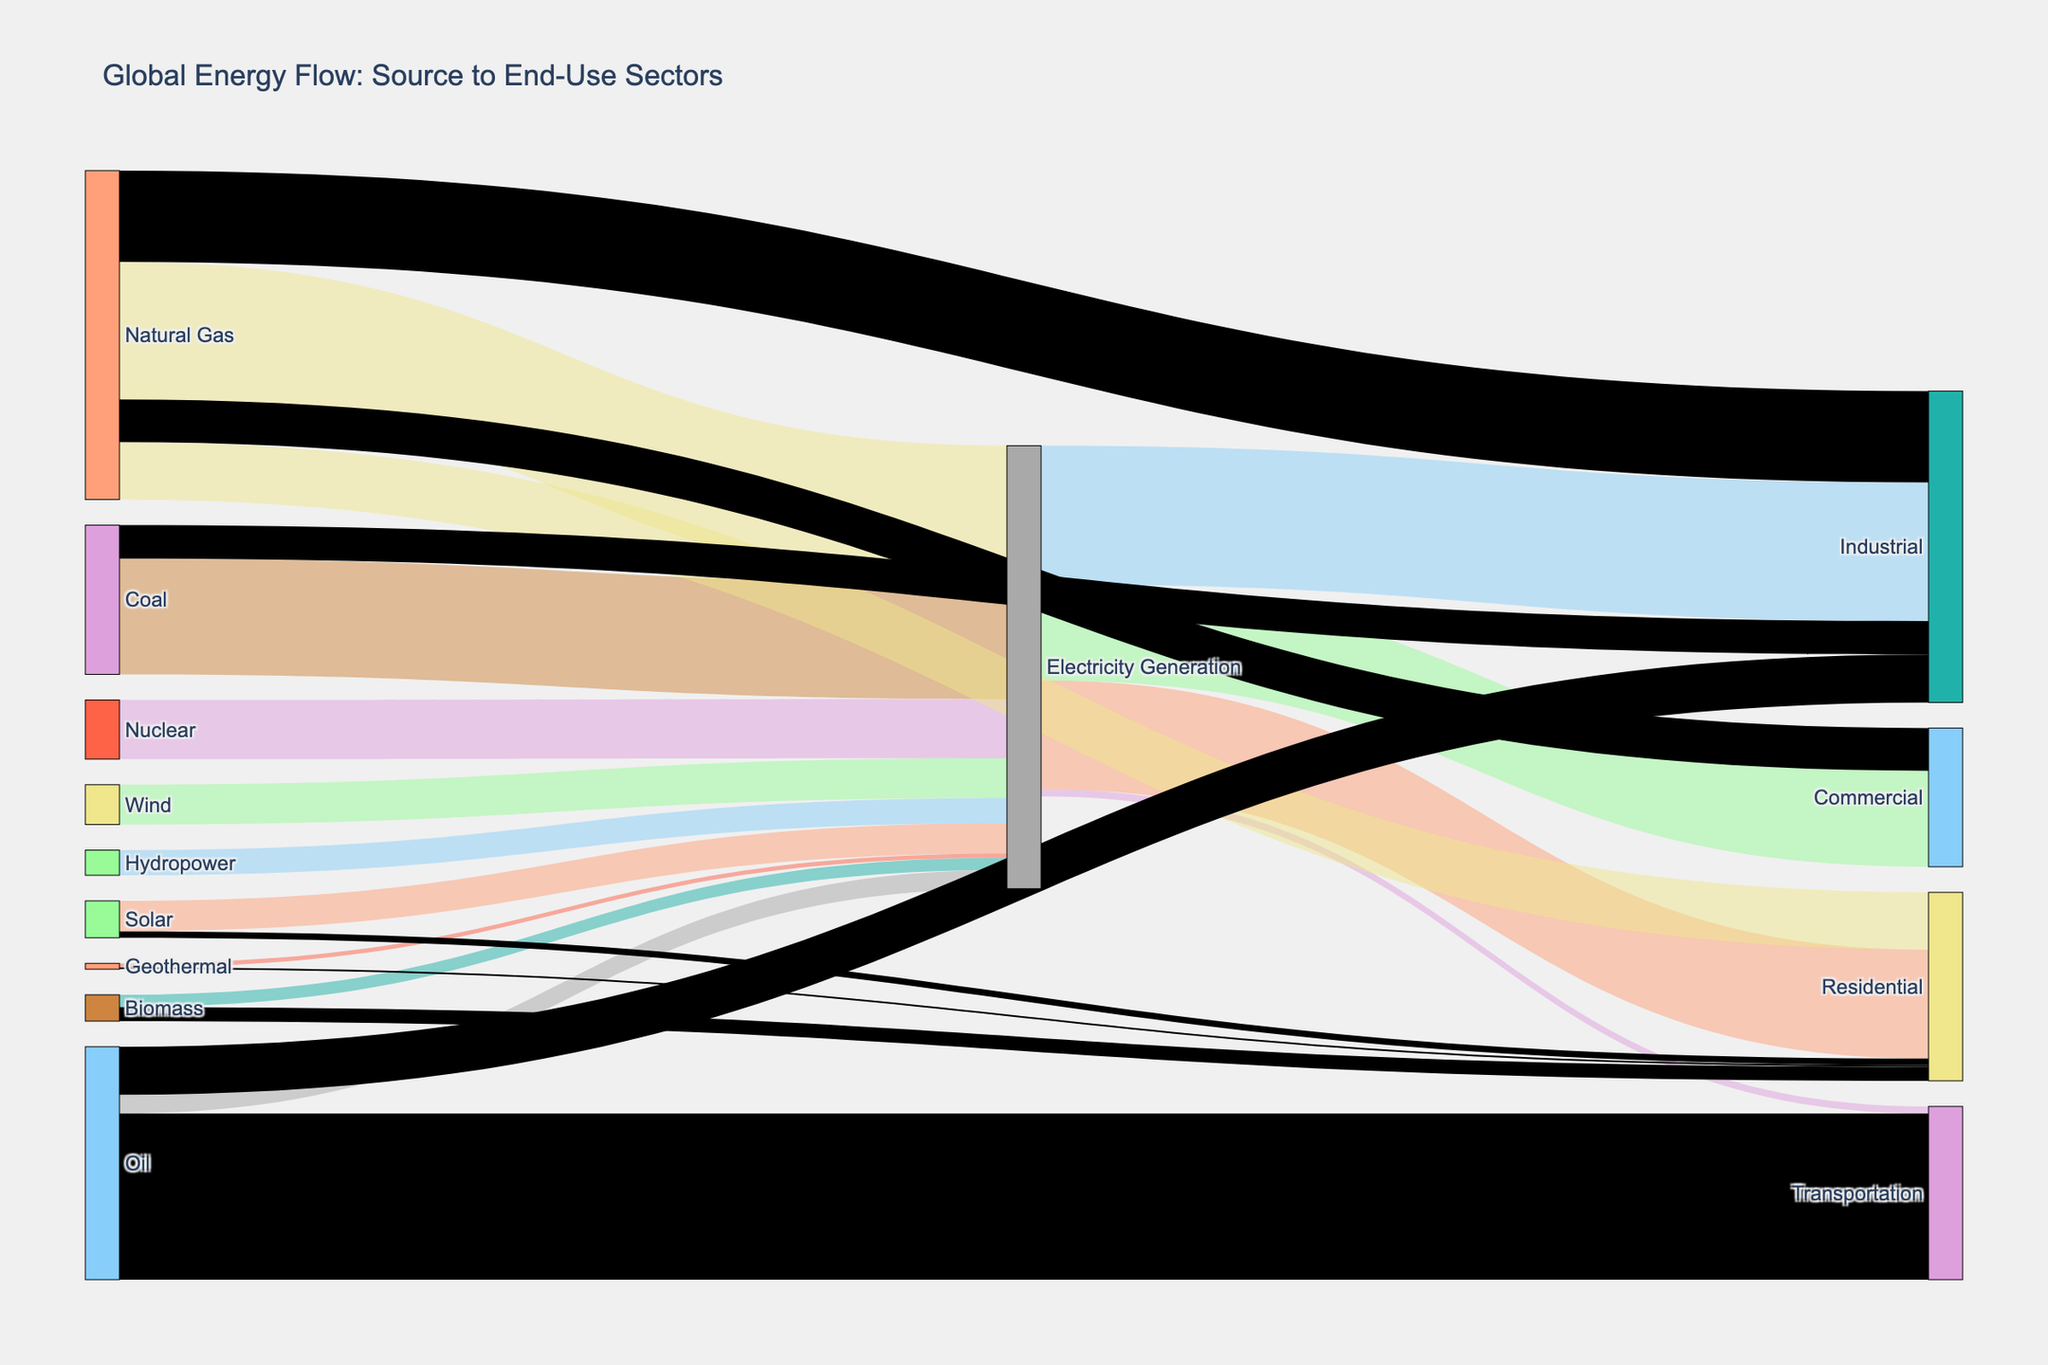what is the highest value used directly for residential purposes from renewable sources? To determine the highest value used for residential purposes from renewable sources, we must look for entries with 'Residential' as the target and source being renewable energy (Solar, Wind, Hydropower, Biomass, Geothermal). Biomass has a value of 2.4, Solar is 1.1, and Geothermal is 0.3.
Answer: Biomass (2.4) Which energy source contributes the most to electricity generation? We need to identify the energy source with the highest value directed towards 'Electricity Generation'. Natural Gas contributes 23.5, Coal 19.8, Nuclear 10.1, Wind 6.8, Solar 5.2, Hydropower 4.3, Oil 3.2, Biomass 2.1, Geothermal 0.7. Natural Gas has the highest contribution.
Answer: Natural Gas (23.5) What is the total energy flow from renewable sources? First, sum the value of all renewable sources (Solar, Wind, Hydropower, Biomass, Geothermal) across all targets. Solar (5.2 + 1.1 = 6.3), Wind (6.8), Hydropower (4.3), Biomass (2.1 + 2.4 = 4.5), Geothermal (0.7 + 0.3 = 1.0). Summing these up, 6.3 + 6.8 + 4.3 + 4.5 + 1.0 = 22.9.
Answer: 22.9 Which sector uses the least amount of electricity? Examine which target (Residential, Commercial, Industrial, Transportation) connected to 'Electricity Generation' has the smallest value. Residential is 18.6, Commercial is 16.4, Industrial is 23.7, Transportation is 1.2. Transportation uses the least.
Answer: Transportation (1.2) How does the total energy used in residential compare to commercial? Sum the values directed to 'Residential' and 'Commercial' across all sources. Residential: Electricity Generation (18.6), Natural Gas (9.8), Biomass (2.4), Solar (1.1), Geothermal (0.3). Total: 18.6 + 9.8 + 2.4 + 1.1 + 0.3 = 32.2. Commercial: Electricity Generation (16.4), Natural Gas (7.3). Total: 16.4 + 7.3 = 23.7. Residential usage is higher.
Answer: Residential (32.2) > Commercial (23.7) What is the combined energy use for the Industrial sector? Add up all energy flows directed to 'Industrial'. Electricity Generation (23.7), Natural Gas (15.6), Oil (8.2), Coal (5.7). Sum: 23.7 + 15.6 + 8.2 + 5.7 = 53.2.
Answer: 53.2 Which renewable energy sources are not used directly for residential purposes? Identify renewable sources (Solar, Wind, Hydropower, Biomass, Geothermal) that do not directly target 'Residential'. Solar (1.1), Biomass (2.4), Geothermal (0.3) are used. Wind and Hydropower are not direct sources for residential.
Answer: Wind, Hydropower 